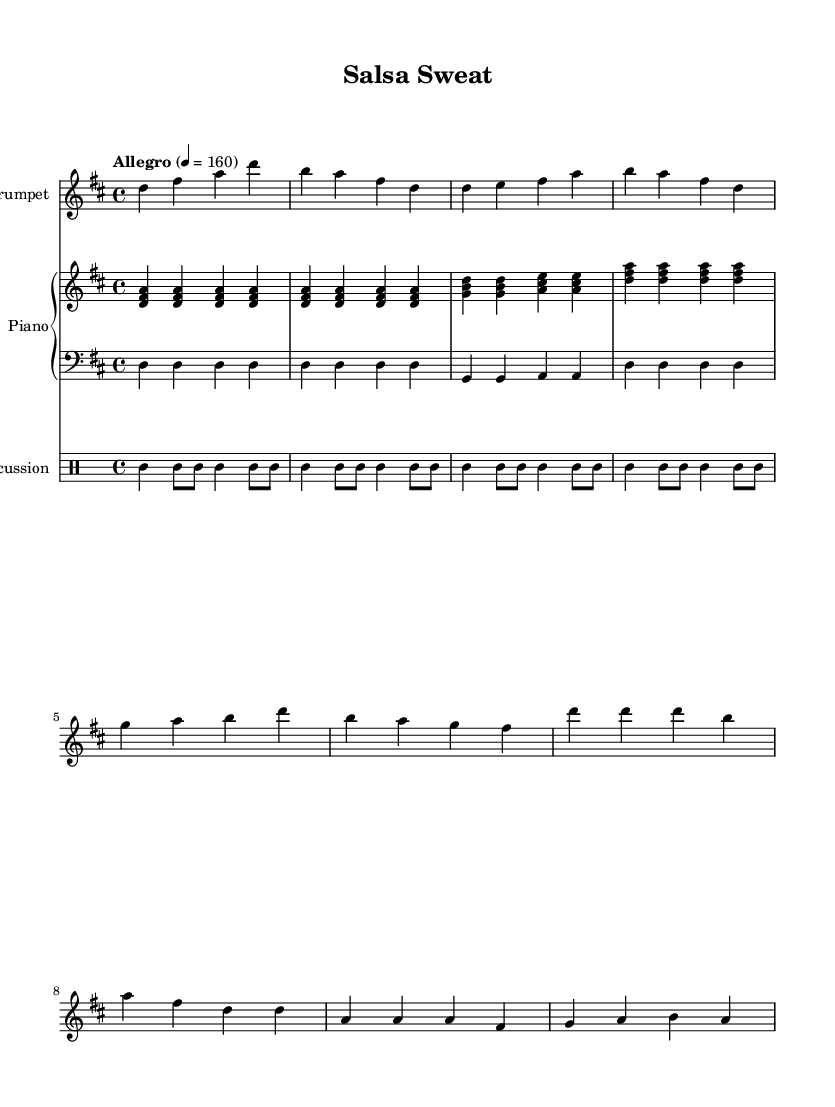What is the key signature of this music? The key signature is D major, indicated by the presence of two sharps (F# and C#) in the key signature section.
Answer: D major What is the time signature of this piece? The time signature is 4/4, which is commonly found at the beginning of the piece and indicated by the notation that shows four beats per measure.
Answer: 4/4 What is the tempo marking for this music? The tempo marking is "Allegro," which translates to a fast and lively tempo, and is specified as 160 beats per minute.
Answer: Allegro How many measures are there in the trumpet part? Counting the measures visually from the staff of the trumpet section shows a total of eight measures.
Answer: Eight What is the rhythmic pattern used in the drums? The drum part uses a consistent rhythmic pattern of quarter notes and eighth notes that creates a driving beat suitable for high-energy workouts.
Answer: Driving beat What instruments are included in this score? The score includes trumpet, piano, bass, and percussion, as indicated by the labeled staves for each instrument.
Answer: Trumpet, piano, bass, percussion What type of Latin music does this piece represent? Given the rhythmic structure and instrumentation, this piece represents Salsa music, which is characterized by its upbeat tempo and engaging rhythms.
Answer: Salsa 